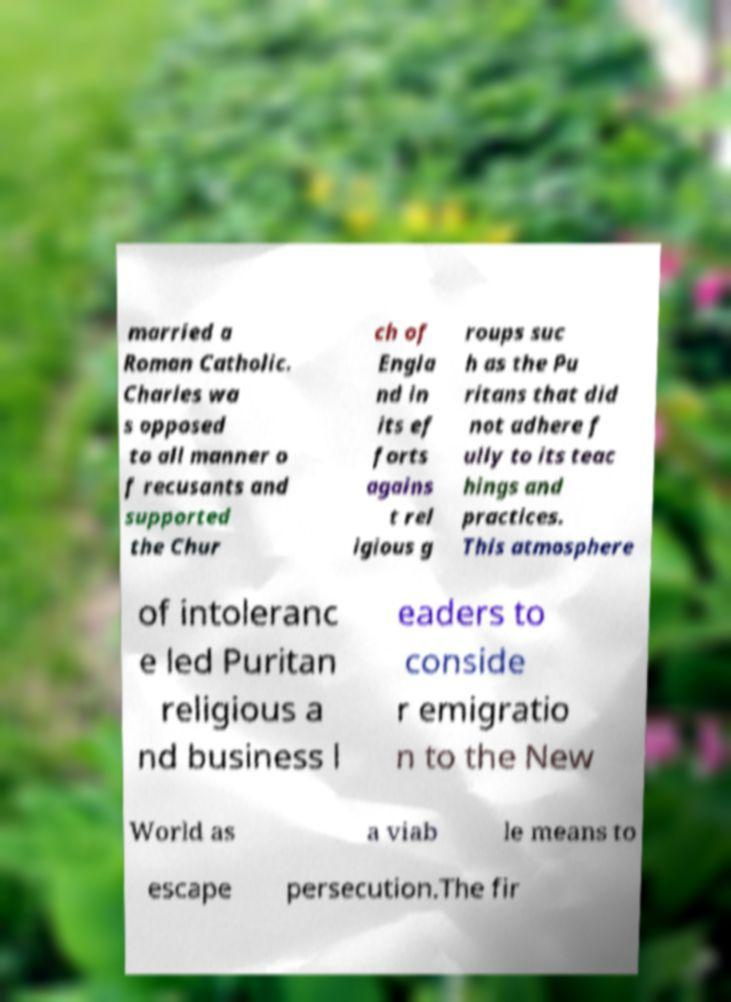Please read and relay the text visible in this image. What does it say? married a Roman Catholic. Charles wa s opposed to all manner o f recusants and supported the Chur ch of Engla nd in its ef forts agains t rel igious g roups suc h as the Pu ritans that did not adhere f ully to its teac hings and practices. This atmosphere of intoleranc e led Puritan religious a nd business l eaders to conside r emigratio n to the New World as a viab le means to escape persecution.The fir 